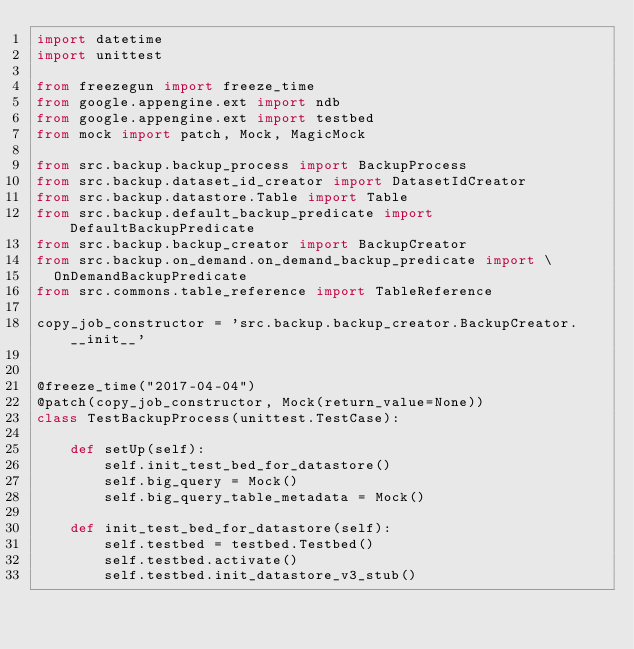Convert code to text. <code><loc_0><loc_0><loc_500><loc_500><_Python_>import datetime
import unittest

from freezegun import freeze_time
from google.appengine.ext import ndb
from google.appengine.ext import testbed
from mock import patch, Mock, MagicMock

from src.backup.backup_process import BackupProcess
from src.backup.dataset_id_creator import DatasetIdCreator
from src.backup.datastore.Table import Table
from src.backup.default_backup_predicate import DefaultBackupPredicate
from src.backup.backup_creator import BackupCreator
from src.backup.on_demand.on_demand_backup_predicate import \
  OnDemandBackupPredicate
from src.commons.table_reference import TableReference

copy_job_constructor = 'src.backup.backup_creator.BackupCreator.__init__'


@freeze_time("2017-04-04")
@patch(copy_job_constructor, Mock(return_value=None))
class TestBackupProcess(unittest.TestCase):

    def setUp(self):
        self.init_test_bed_for_datastore()
        self.big_query = Mock()
        self.big_query_table_metadata = Mock()

    def init_test_bed_for_datastore(self):
        self.testbed = testbed.Testbed()
        self.testbed.activate()
        self.testbed.init_datastore_v3_stub()</code> 